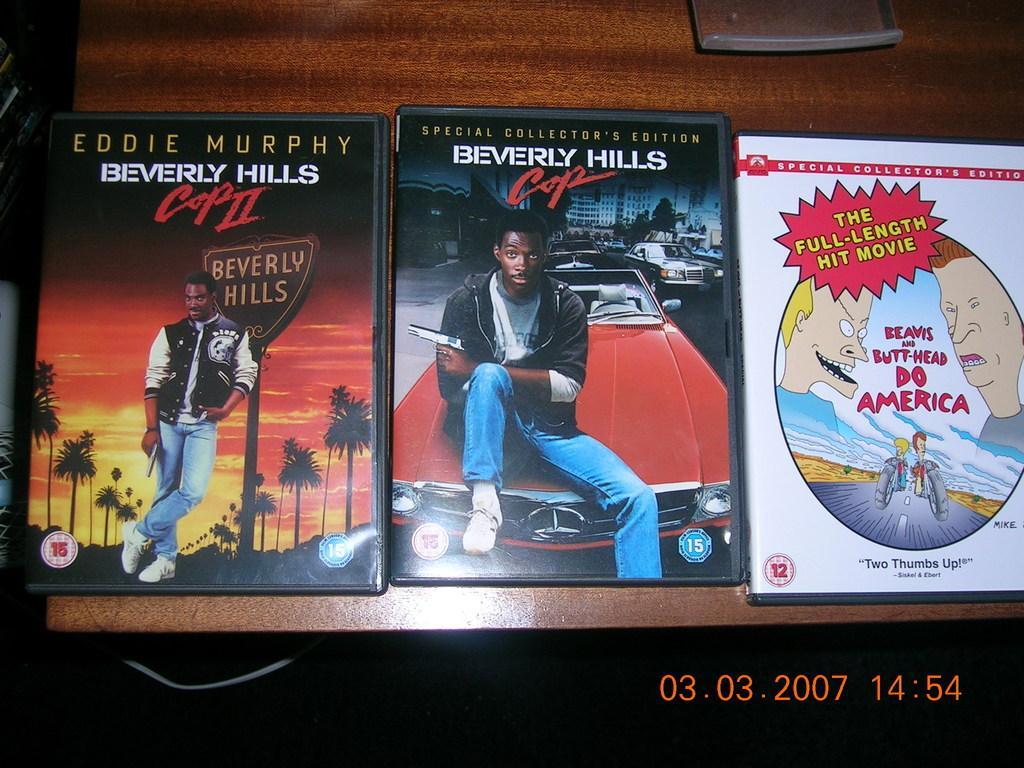Can you describe this image briefly? In this picture we can see posters on a wooden surface and on these posters we can see some people, buildings, cars, trees, name board and some text and in the background we can see some objects. 